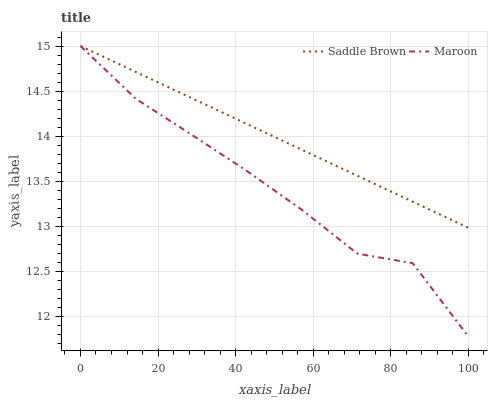Does Maroon have the maximum area under the curve?
Answer yes or no. No. Is Maroon the smoothest?
Answer yes or no. No. 